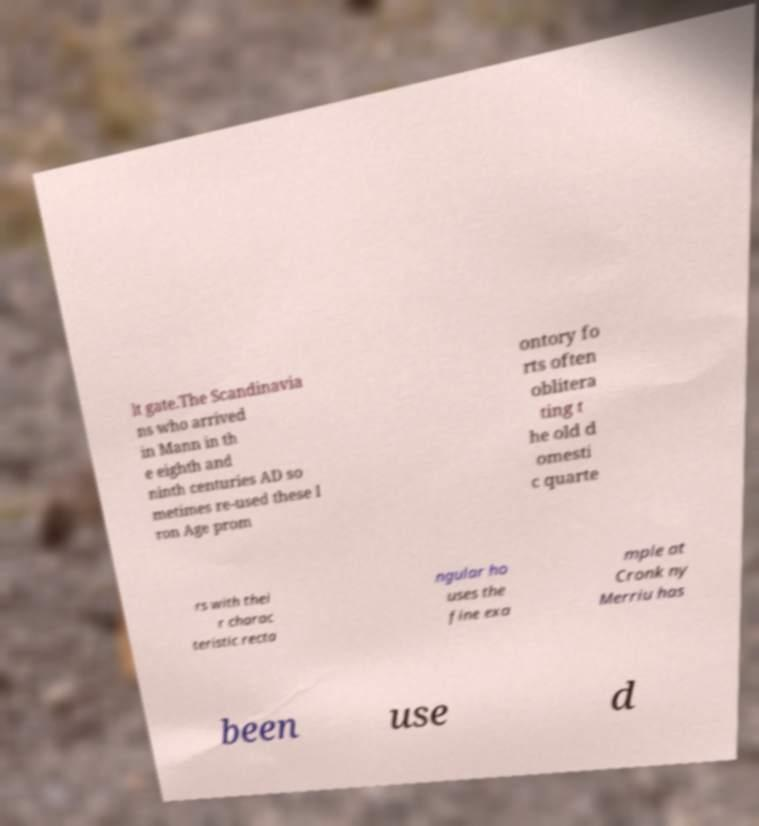Could you extract and type out the text from this image? lt gate.The Scandinavia ns who arrived in Mann in th e eighth and ninth centuries AD so metimes re-used these I ron Age prom ontory fo rts often oblitera ting t he old d omesti c quarte rs with thei r charac teristic recta ngular ho uses the fine exa mple at Cronk ny Merriu has been use d 